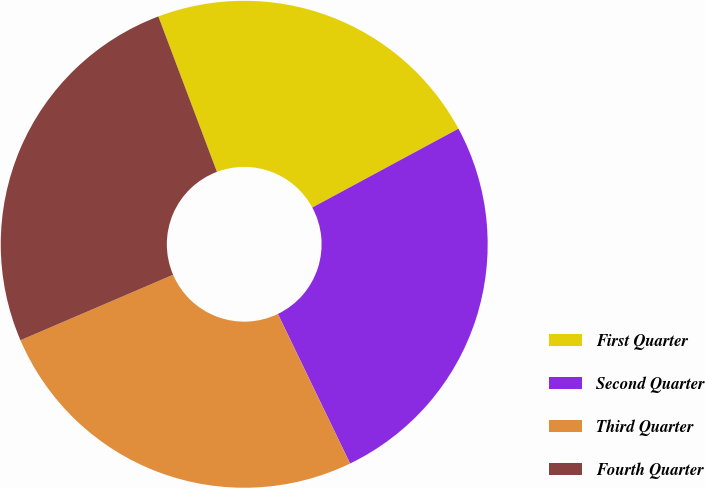Convert chart. <chart><loc_0><loc_0><loc_500><loc_500><pie_chart><fcel>First Quarter<fcel>Second Quarter<fcel>Third Quarter<fcel>Fourth Quarter<nl><fcel>22.86%<fcel>25.71%<fcel>25.71%<fcel>25.71%<nl></chart> 